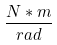<formula> <loc_0><loc_0><loc_500><loc_500>\frac { N * m } { r a d }</formula> 